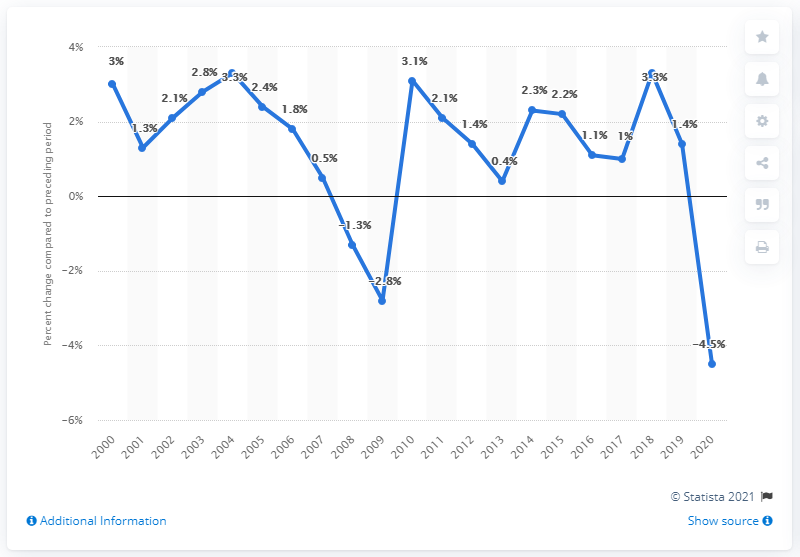Mention a couple of crucial points in this snapshot. Wisconsin's Gross Domestic Product (GDP) increased by 3.3% in 2018 compared to the previous year. 